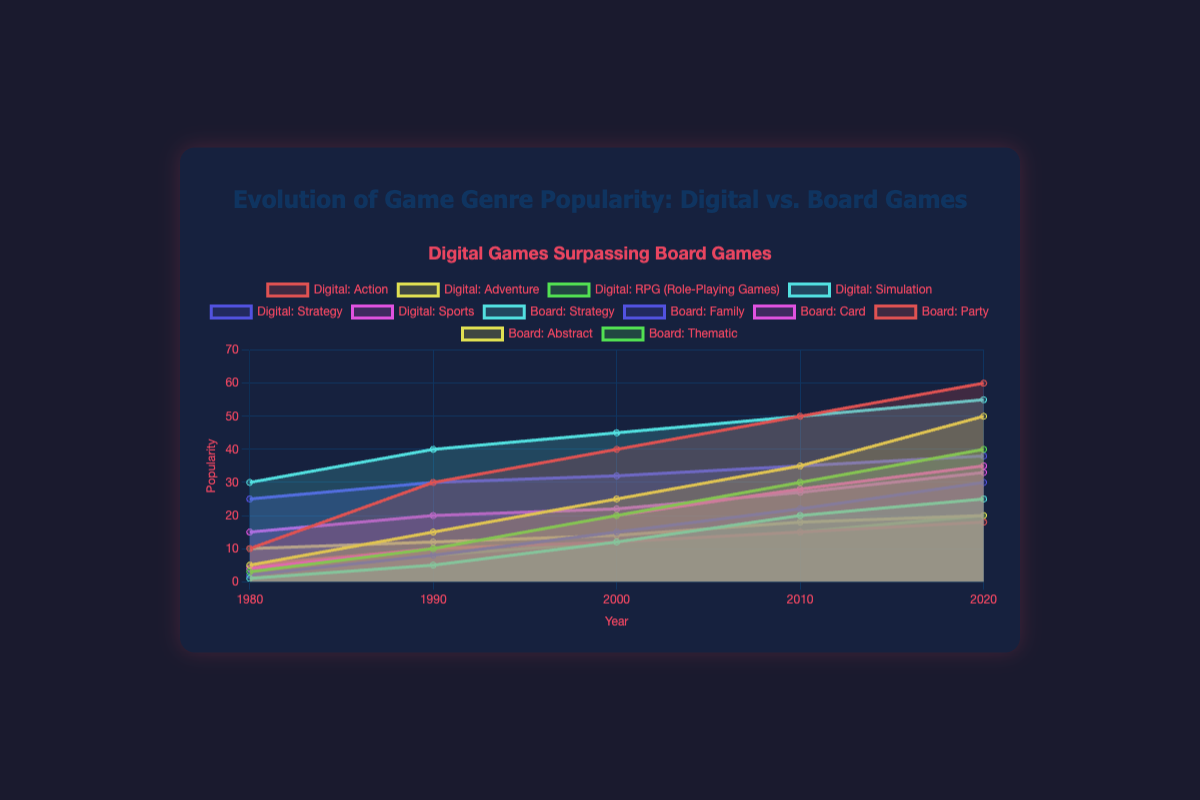Which genre of digital games has shown the most consistent growth in popularity over time? To determine which genre of digital games has shown the most consistent growth, look for a genre with a steady increase in popularity from 1980 to 2020. All genres show some growth, but "Action" and "Adventure" both show a fairly steady increase. "Action" starts at 10 and ends at 60 without any dip, indicating consistent growth.
Answer: Action Which year saw the highest collective popularity for board games? To find the year with the highest collective popularity for board games, sum the popularity of all board game genres for each year. The sums are: 1980 (87), 1990 (120), 2000 (137), 2010 (160), 2020 (184). Hence, 2020 has the highest sum.
Answer: 2020 By how much did the popularity of "Simulation" games in digital gaming increase from 1980 to 2020? Subtract the value of the "Simulation" genre in 1980 from its value in 2020. In 1980, "Simulation" is at 1, and in 2020, it is at 25. So, the increase is 25 - 1 = 24.
Answer: 24 Which genre has a higher popularity in 2020, digital "Adventure" games or board "Strategy" games? Compare the values for "Adventure" in digital games and "Strategy" in board games for 2020. "Adventure" in digital games is at 50, while "Strategy" in board games is at 55.
Answer: Board Strategy How does the popularity growth of "RPG" in digital games compare to "Family" in board games between 1990 and 2020? Calculate the change in popularity for "RPG" in digital games and "Family" in board games from 1990 to 2020. "RPG" increases from 10 to 40 (growth of 30), while "Family" increases from 30 to 38 (growth of 8).
Answer: RPG grows faster Which genre of board games was the least popular in 2000? Look at the values for all board game genres in the year 2000 and find the smallest value. "Thematic" has the lowest value at 12.
Answer: Thematic What is the trend in "Strategy" genre popularity for both digital and board games over time? Examine the "Strategy" genre for both digital games and board games from 1980 to 2020. In digital games, it starts at 2 and grows relentlessly to 30, while in board games, it starts at 30 and rises steadily to 55. Both show an increasing trend.
Answer: Increasing for both Between 1980 and 2020, which game category (digital or board) has seen more variety in genres gaining popularity? Review the number of genres listed and their changing values over time. Digital games have 6 genres, and all show significant growth. Board games also have 6 genres, but the growth is more modest and less varied. This indicates more variety in digital games.
Answer: Digital games 